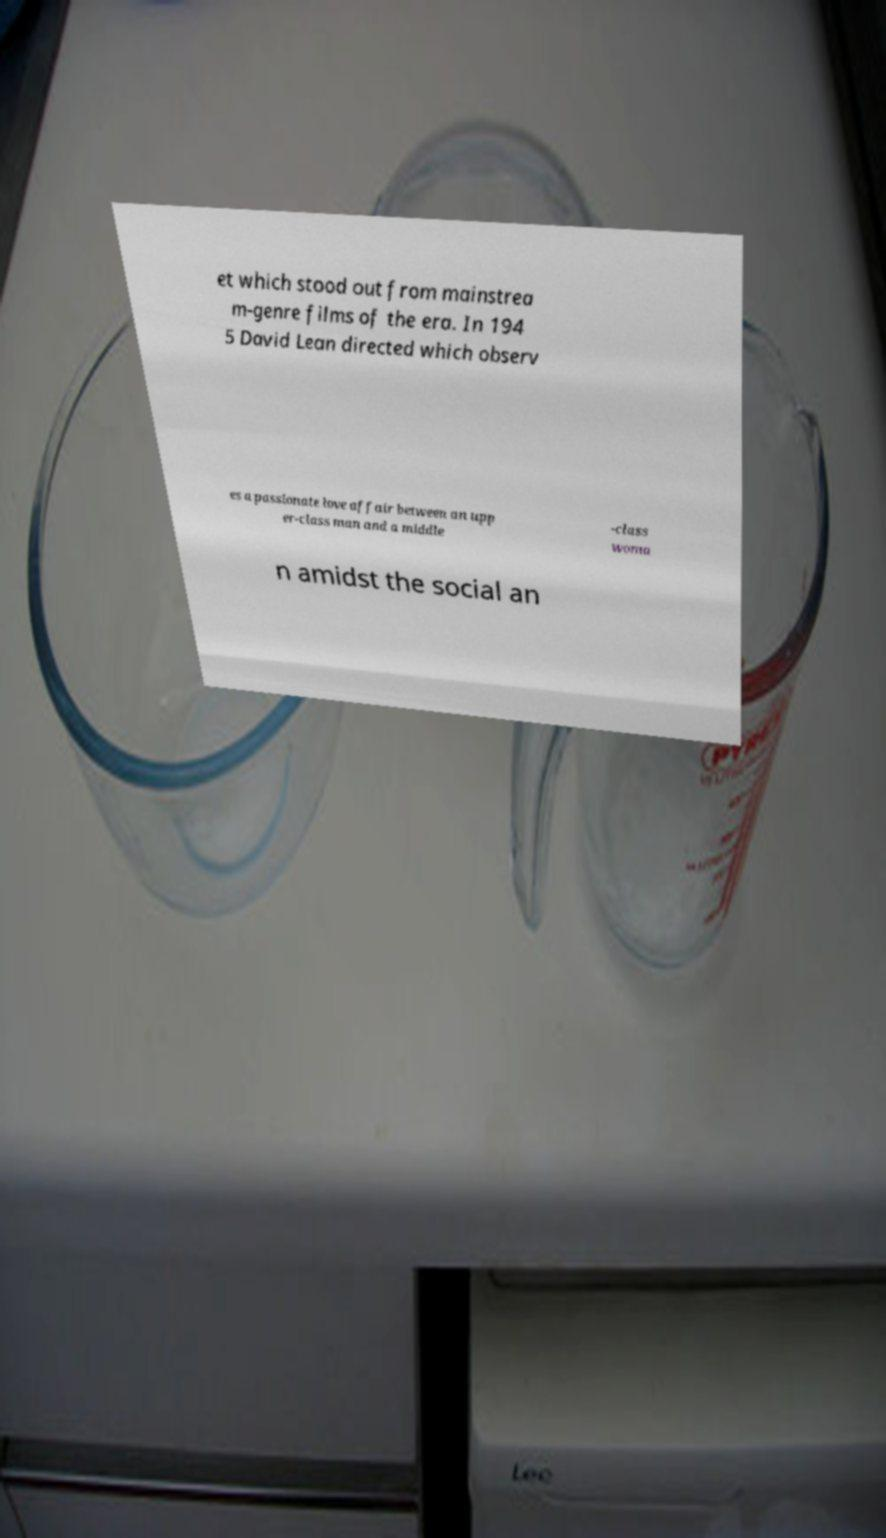Please identify and transcribe the text found in this image. et which stood out from mainstrea m-genre films of the era. In 194 5 David Lean directed which observ es a passionate love affair between an upp er-class man and a middle -class woma n amidst the social an 